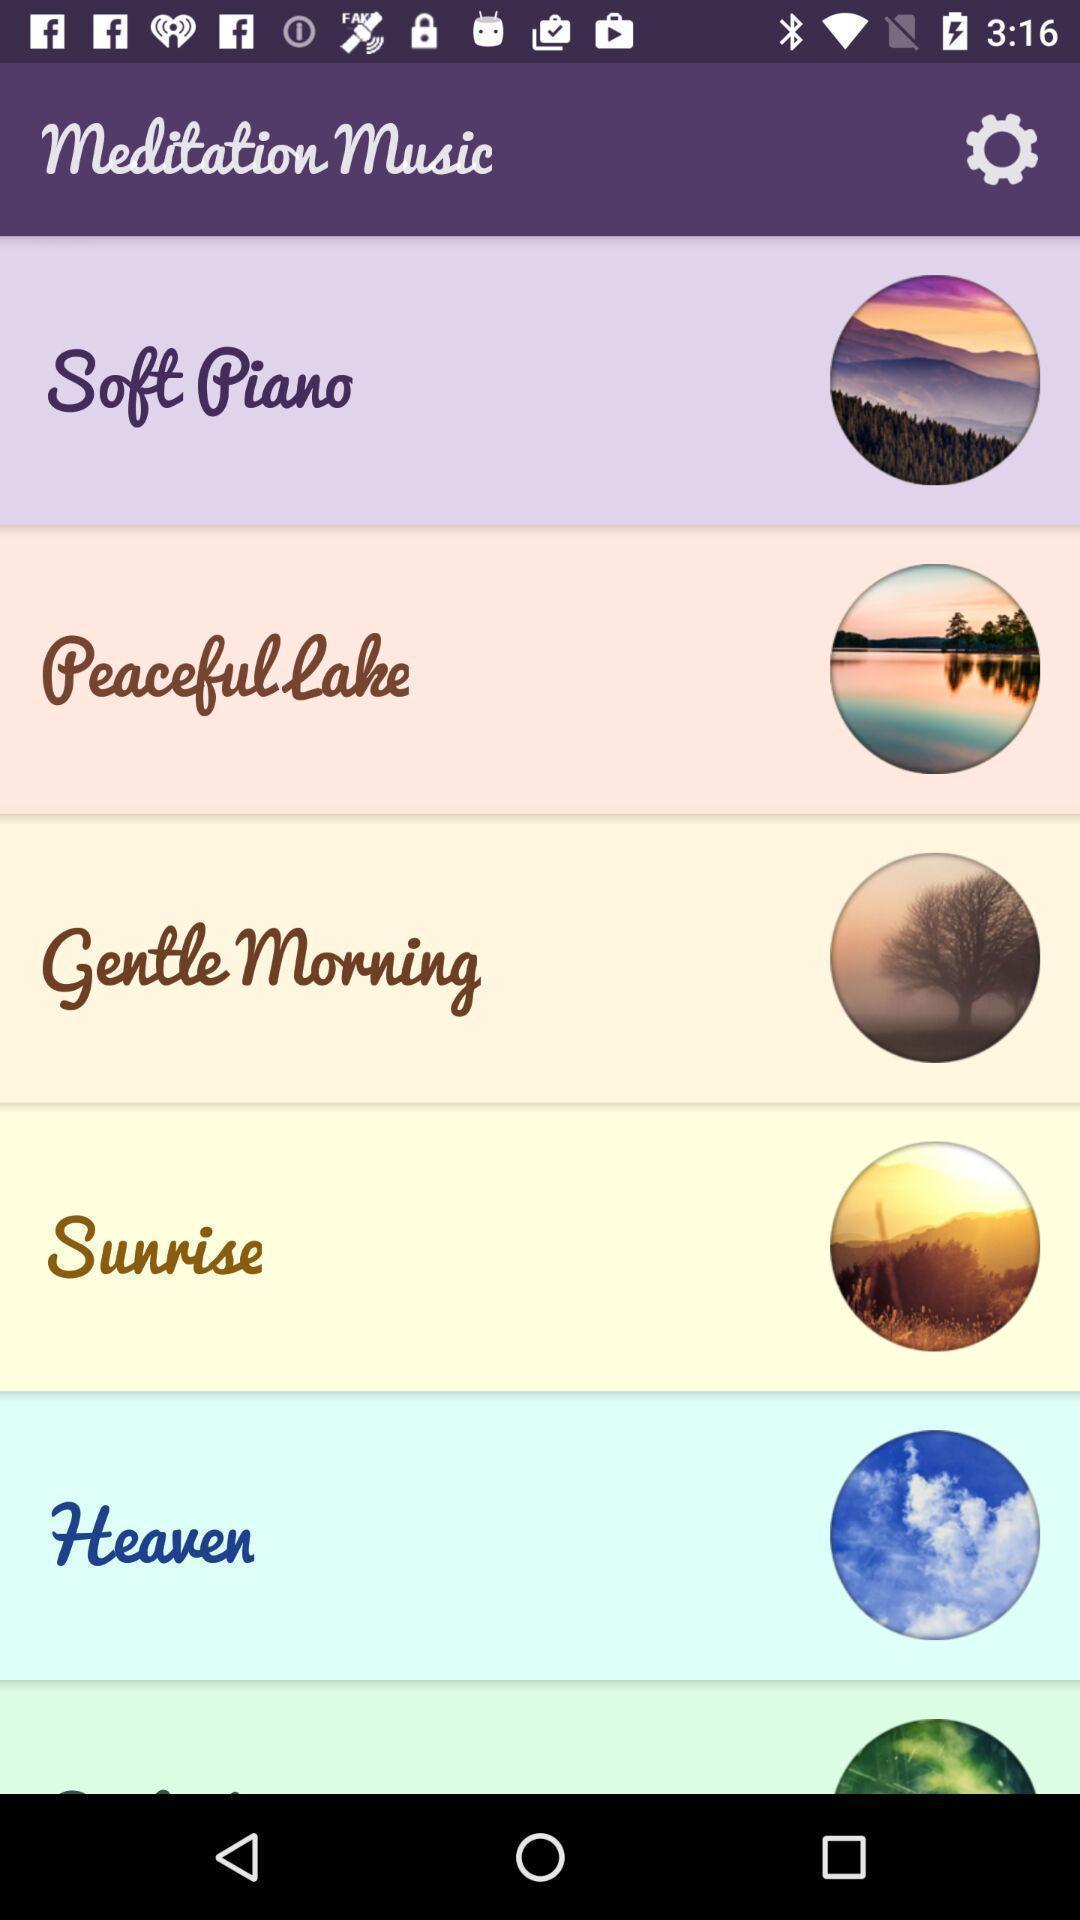Please provide a description for this image. Page showing the different music genres. 